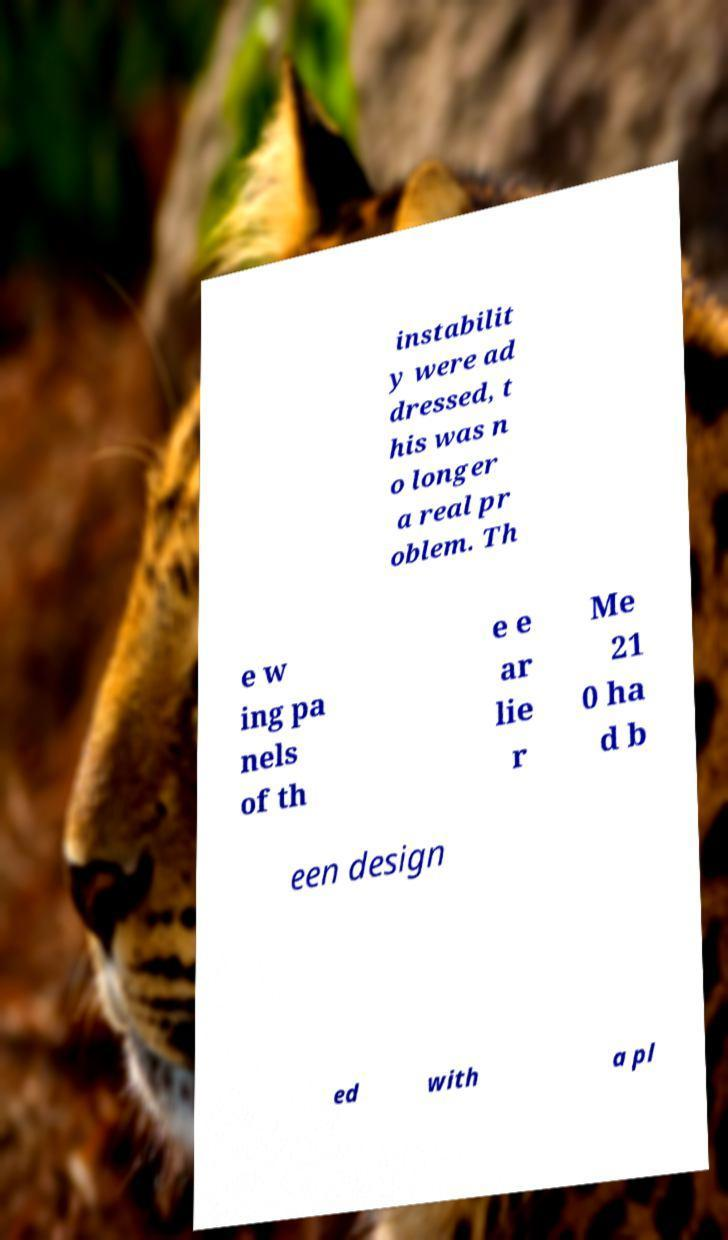What messages or text are displayed in this image? I need them in a readable, typed format. instabilit y were ad dressed, t his was n o longer a real pr oblem. Th e w ing pa nels of th e e ar lie r Me 21 0 ha d b een design ed with a pl 